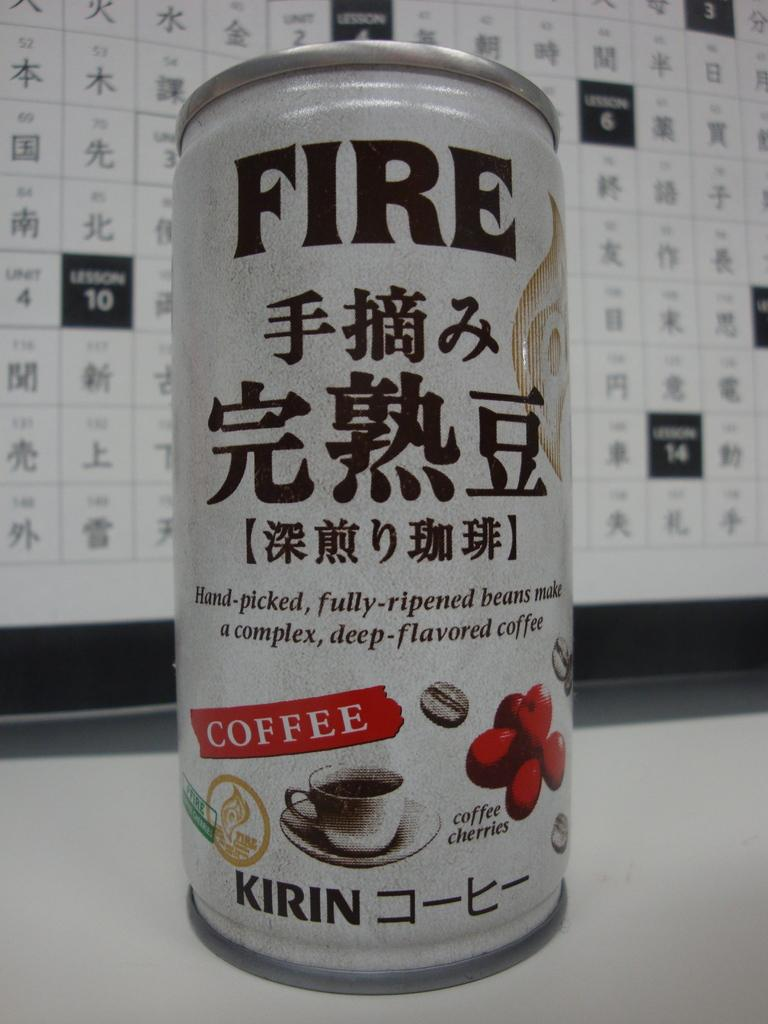<image>
Describe the image concisely. A can of FIRE coffee sits on a table in front of a lesson planner. 